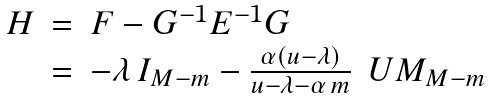<formula> <loc_0><loc_0><loc_500><loc_500>\begin{array} { l l l } H & = & F - G ^ { - 1 } E ^ { - 1 } G \\ & = & - \lambda \, I _ { M - m } - \frac { \alpha ( u - \lambda ) } { u - \lambda - \alpha \, m } \, \ U M _ { M - m } \end{array}</formula> 